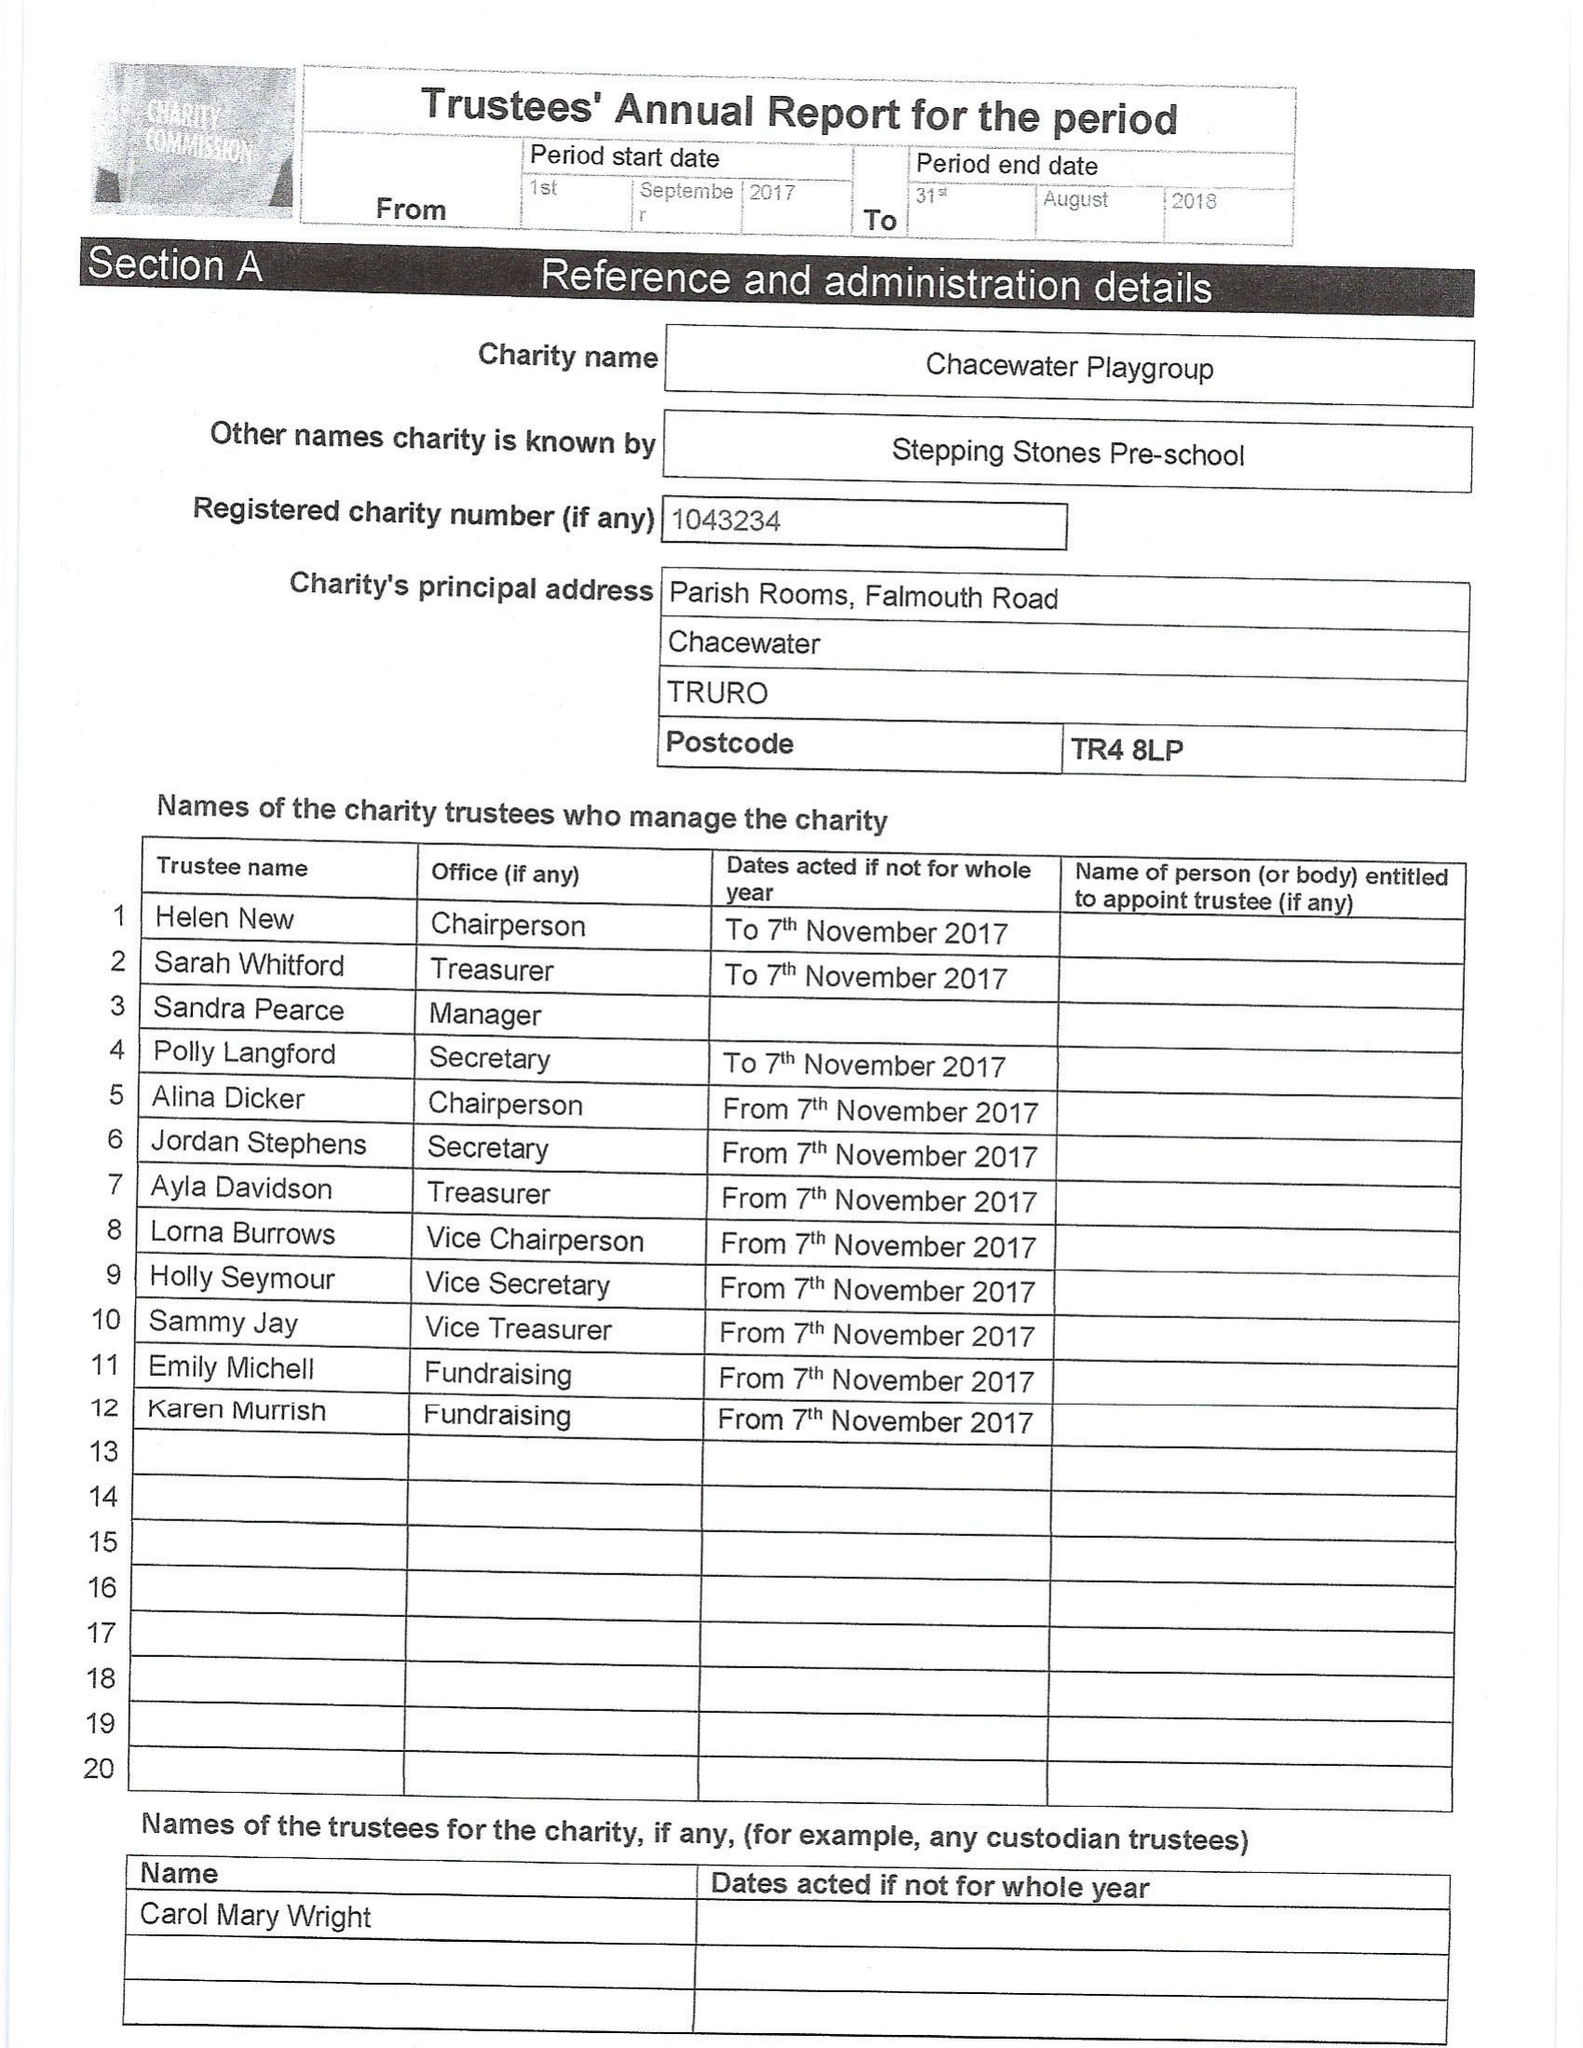What is the value for the spending_annually_in_british_pounds?
Answer the question using a single word or phrase. 58987.00 